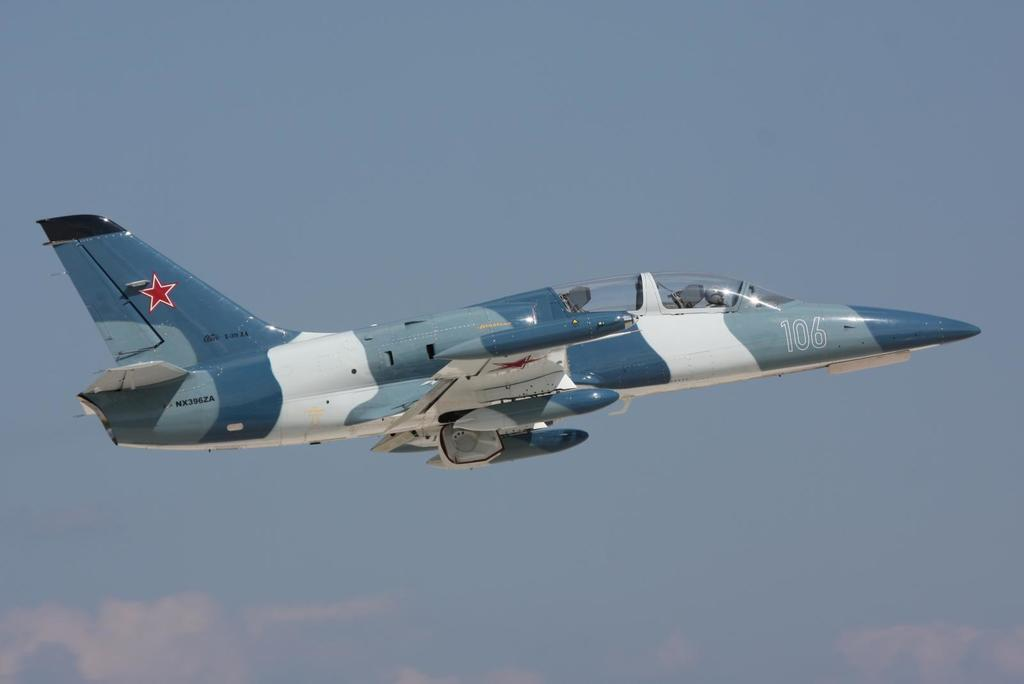What is the main subject of the image? The main subject of the image is an aircraft. What is the aircraft doing in the image? The aircraft is flying in the sky. What can be seen in the sky besides the aircraft? There are patches of clouds in the sky. What type of record is being played on the aircraft in the image? There is no record player or music mentioned in the image; it only features an aircraft flying in the sky with patches of clouds. 